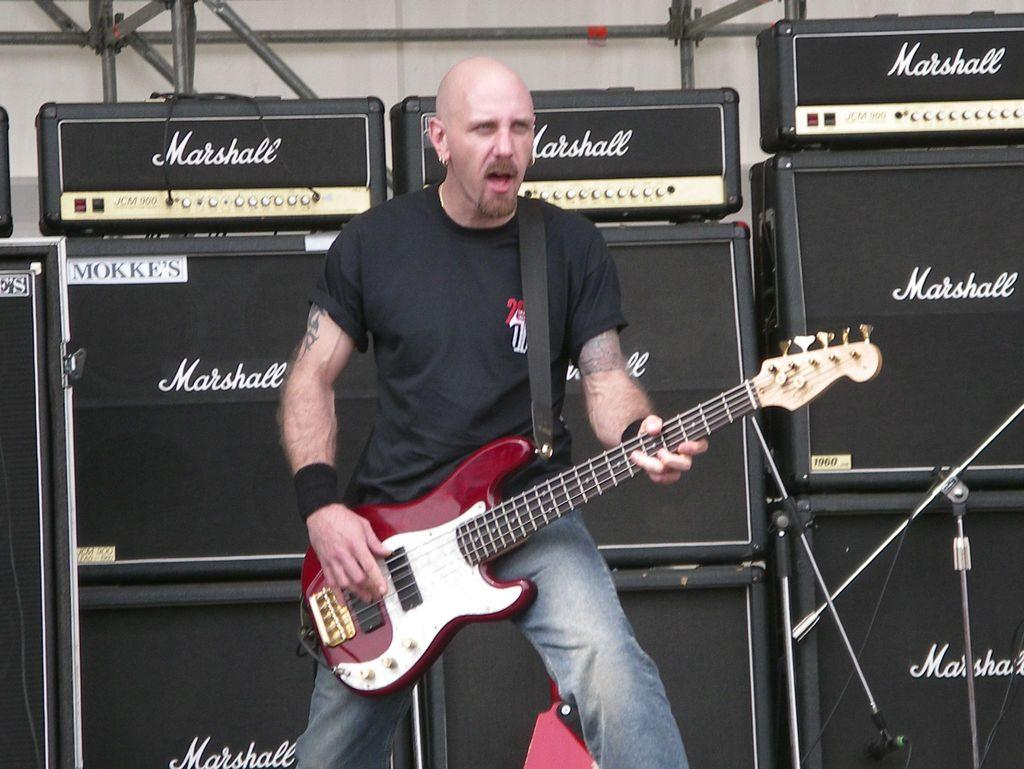What is the man wearing in the image? The man is wearing a black t-shirt. What is the man doing in the image? The man is singing and playing a guitar. Can you describe the devices in the background of the image? There are devices above a box in the background, and this is a mic holder. What type of locket is the man wearing around his neck in the image? There is no locket visible around the man's neck in the image. What health advice can be given to the man based on his activities in the image? There is no health advice that can be given based on the man's activities in the image, as we do not have enough information about his health or the context of the image. 